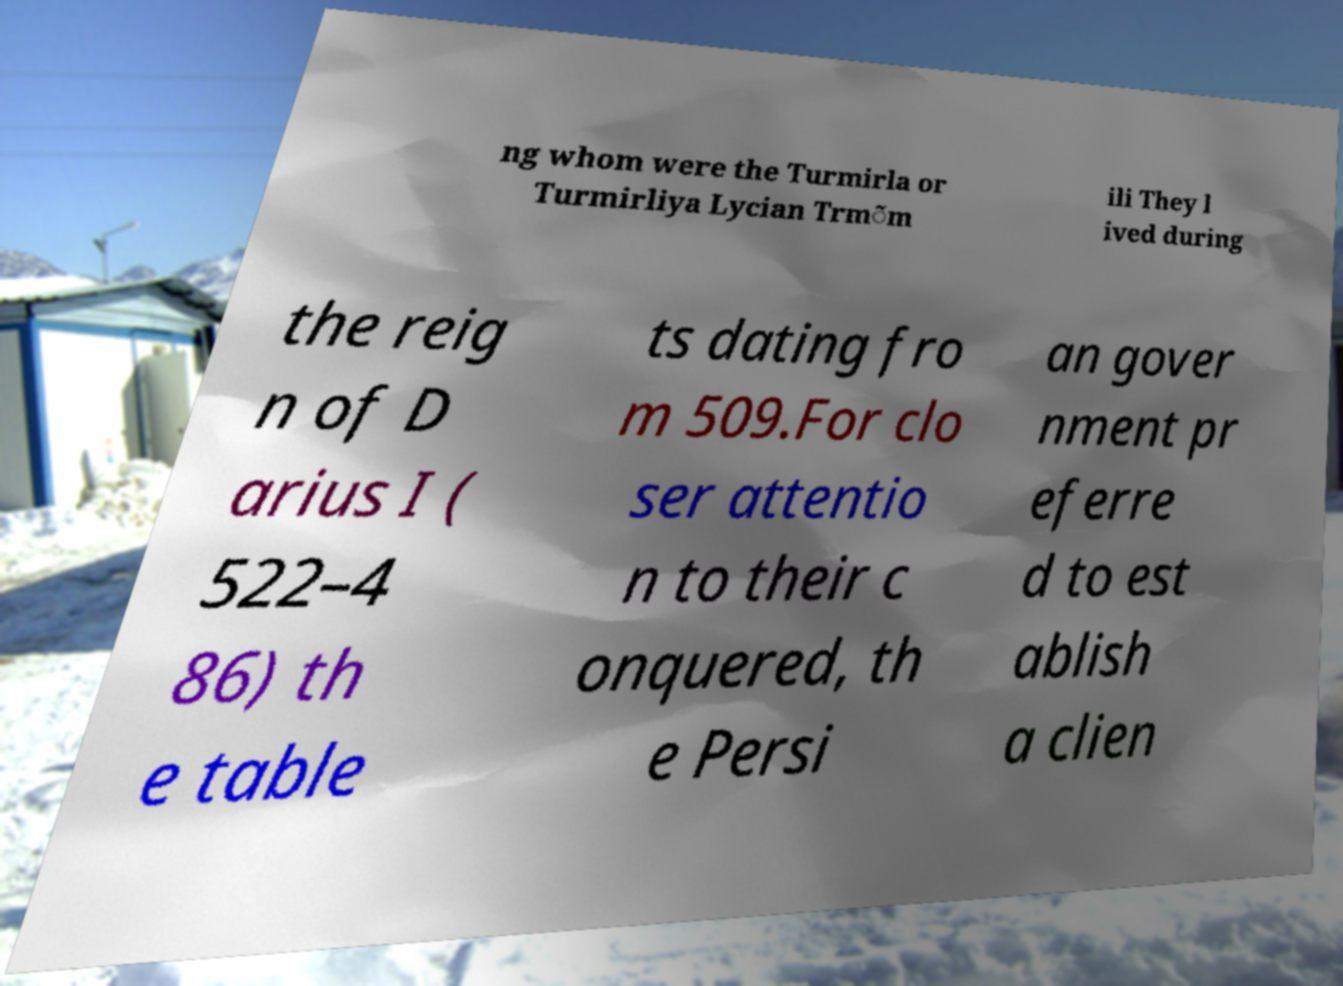There's text embedded in this image that I need extracted. Can you transcribe it verbatim? ng whom were the Turmirla or Turmirliya Lycian Trm̃m ili They l ived during the reig n of D arius I ( 522–4 86) th e table ts dating fro m 509.For clo ser attentio n to their c onquered, th e Persi an gover nment pr eferre d to est ablish a clien 